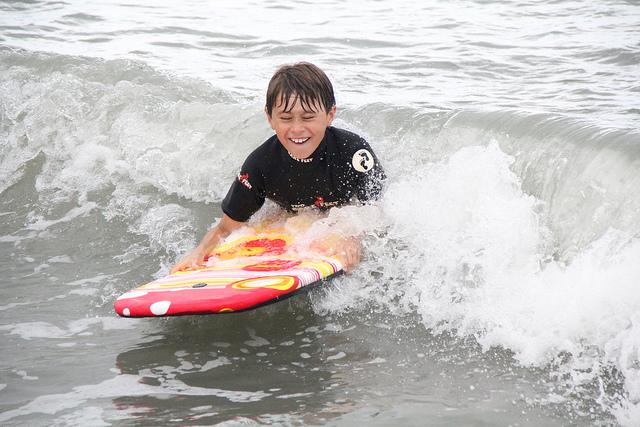What number is on his shoulder?
Write a very short answer. 2. What is the approximate age of the person?
Short answer required. 11. Has the wave crested?
Be succinct. Yes. 